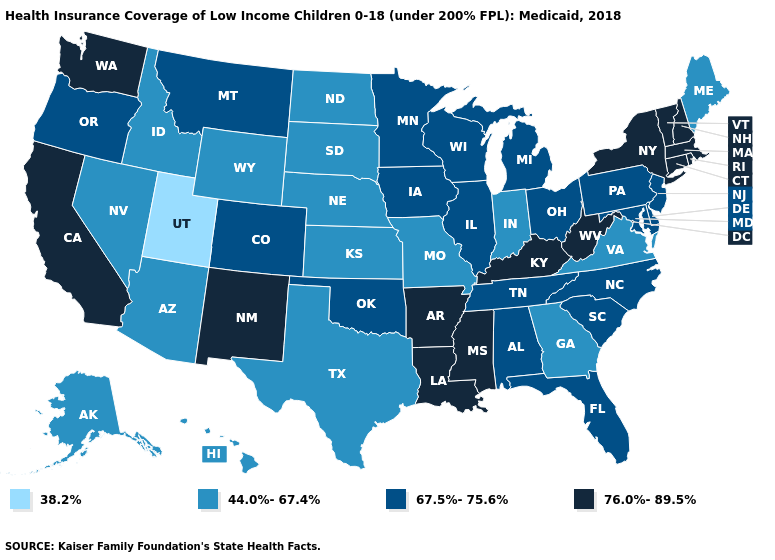What is the highest value in the West ?
Concise answer only. 76.0%-89.5%. Among the states that border Colorado , does Utah have the lowest value?
Keep it brief. Yes. What is the value of Minnesota?
Quick response, please. 67.5%-75.6%. What is the value of Rhode Island?
Short answer required. 76.0%-89.5%. What is the highest value in states that border Oklahoma?
Quick response, please. 76.0%-89.5%. Does Utah have the lowest value in the USA?
Give a very brief answer. Yes. Name the states that have a value in the range 67.5%-75.6%?
Quick response, please. Alabama, Colorado, Delaware, Florida, Illinois, Iowa, Maryland, Michigan, Minnesota, Montana, New Jersey, North Carolina, Ohio, Oklahoma, Oregon, Pennsylvania, South Carolina, Tennessee, Wisconsin. What is the lowest value in the South?
Give a very brief answer. 44.0%-67.4%. Is the legend a continuous bar?
Be succinct. No. Does the map have missing data?
Short answer required. No. Does the first symbol in the legend represent the smallest category?
Write a very short answer. Yes. Does Montana have the highest value in the West?
Answer briefly. No. Does California have the highest value in the West?
Quick response, please. Yes. Is the legend a continuous bar?
Short answer required. No. Does the first symbol in the legend represent the smallest category?
Quick response, please. Yes. 